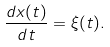<formula> <loc_0><loc_0><loc_500><loc_500>\frac { d x ( t ) } { d t } = \xi ( t ) .</formula> 